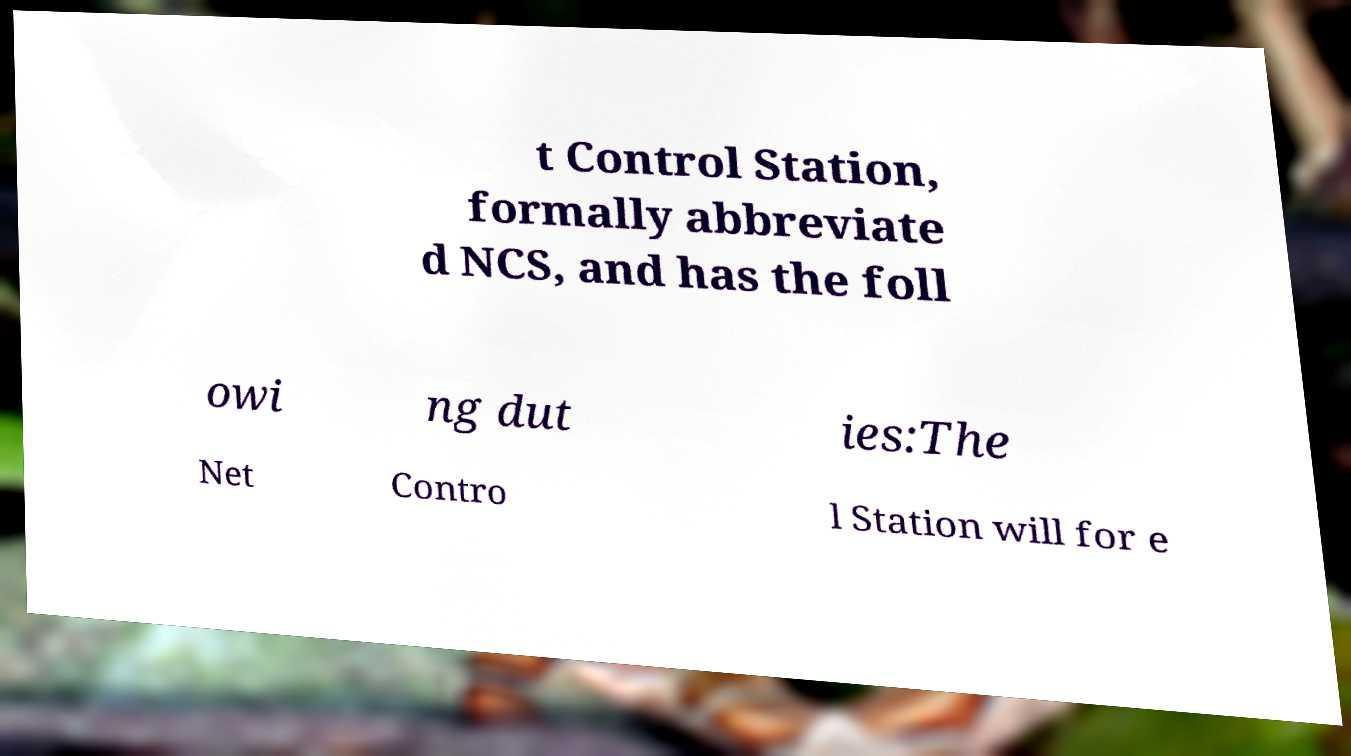I need the written content from this picture converted into text. Can you do that? t Control Station, formally abbreviate d NCS, and has the foll owi ng dut ies:The Net Contro l Station will for e 